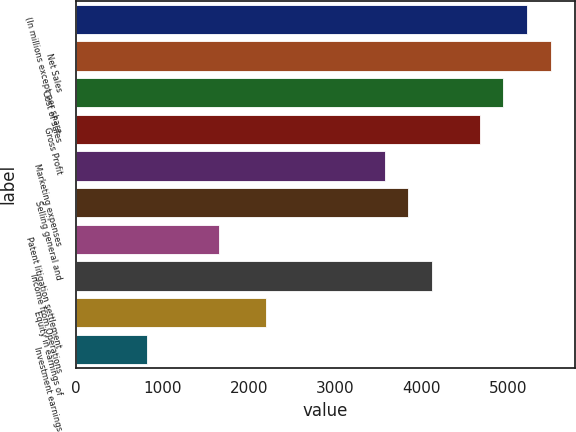Convert chart to OTSL. <chart><loc_0><loc_0><loc_500><loc_500><bar_chart><fcel>(In millions except per share<fcel>Net Sales<fcel>Cost of sales<fcel>Gross Profit<fcel>Marketing expenses<fcel>Selling general and<fcel>Patent litigation settlement<fcel>Income from Operations<fcel>Equity in earnings of<fcel>Investment earnings<nl><fcel>5223.32<fcel>5498.2<fcel>4948.44<fcel>4673.55<fcel>3574<fcel>3848.89<fcel>1649.78<fcel>4123.77<fcel>2199.55<fcel>825.12<nl></chart> 